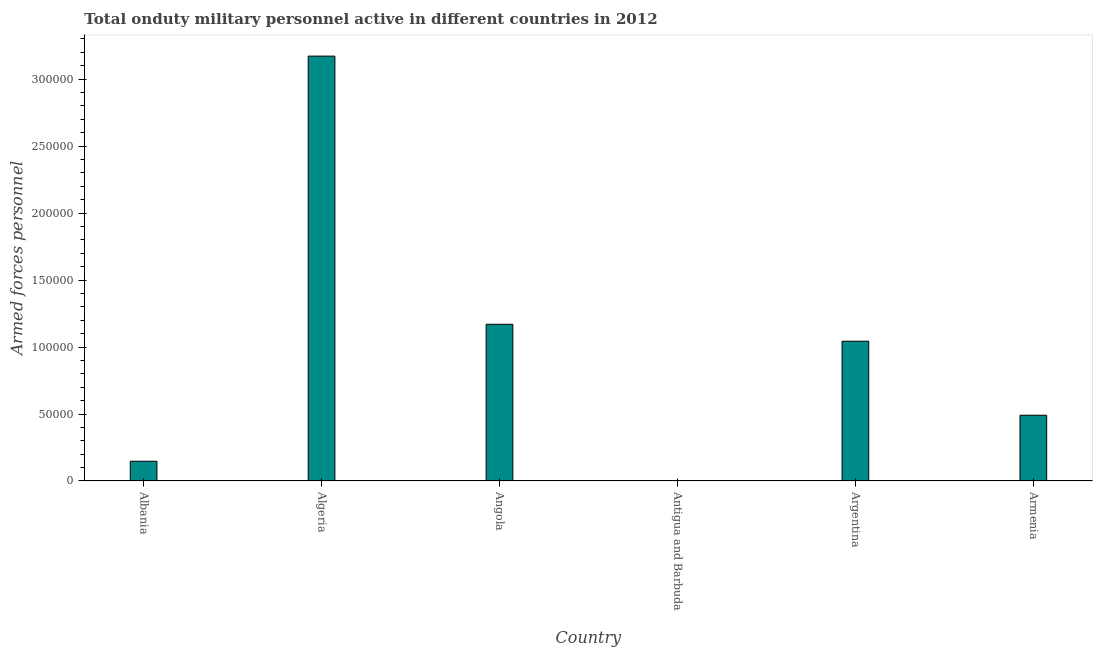Does the graph contain any zero values?
Your answer should be compact. No. Does the graph contain grids?
Your answer should be very brief. No. What is the title of the graph?
Your response must be concise. Total onduty military personnel active in different countries in 2012. What is the label or title of the Y-axis?
Offer a very short reply. Armed forces personnel. What is the number of armed forces personnel in Albania?
Keep it short and to the point. 1.48e+04. Across all countries, what is the maximum number of armed forces personnel?
Provide a succinct answer. 3.17e+05. Across all countries, what is the minimum number of armed forces personnel?
Provide a short and direct response. 180. In which country was the number of armed forces personnel maximum?
Your answer should be compact. Algeria. In which country was the number of armed forces personnel minimum?
Provide a succinct answer. Antigua and Barbuda. What is the sum of the number of armed forces personnel?
Offer a very short reply. 6.03e+05. What is the difference between the number of armed forces personnel in Argentina and Armenia?
Provide a succinct answer. 5.52e+04. What is the average number of armed forces personnel per country?
Offer a very short reply. 1.00e+05. What is the median number of armed forces personnel?
Your answer should be very brief. 7.67e+04. In how many countries, is the number of armed forces personnel greater than 100000 ?
Offer a very short reply. 3. What is the ratio of the number of armed forces personnel in Antigua and Barbuda to that in Armenia?
Provide a short and direct response. 0. Is the number of armed forces personnel in Antigua and Barbuda less than that in Armenia?
Keep it short and to the point. Yes. Is the difference between the number of armed forces personnel in Angola and Antigua and Barbuda greater than the difference between any two countries?
Your answer should be compact. No. What is the difference between the highest and the second highest number of armed forces personnel?
Your answer should be very brief. 2.00e+05. What is the difference between the highest and the lowest number of armed forces personnel?
Provide a succinct answer. 3.17e+05. Are all the bars in the graph horizontal?
Offer a very short reply. No. What is the Armed forces personnel of Albania?
Offer a terse response. 1.48e+04. What is the Armed forces personnel of Algeria?
Offer a very short reply. 3.17e+05. What is the Armed forces personnel of Angola?
Keep it short and to the point. 1.17e+05. What is the Armed forces personnel of Antigua and Barbuda?
Your answer should be very brief. 180. What is the Armed forces personnel of Argentina?
Your answer should be compact. 1.04e+05. What is the Armed forces personnel of Armenia?
Give a very brief answer. 4.91e+04. What is the difference between the Armed forces personnel in Albania and Algeria?
Offer a terse response. -3.02e+05. What is the difference between the Armed forces personnel in Albania and Angola?
Your answer should be compact. -1.02e+05. What is the difference between the Armed forces personnel in Albania and Antigua and Barbuda?
Your answer should be compact. 1.46e+04. What is the difference between the Armed forces personnel in Albania and Argentina?
Provide a succinct answer. -8.96e+04. What is the difference between the Armed forces personnel in Albania and Armenia?
Give a very brief answer. -3.44e+04. What is the difference between the Armed forces personnel in Algeria and Angola?
Provide a short and direct response. 2.00e+05. What is the difference between the Armed forces personnel in Algeria and Antigua and Barbuda?
Your answer should be compact. 3.17e+05. What is the difference between the Armed forces personnel in Algeria and Argentina?
Keep it short and to the point. 2.13e+05. What is the difference between the Armed forces personnel in Algeria and Armenia?
Give a very brief answer. 2.68e+05. What is the difference between the Armed forces personnel in Angola and Antigua and Barbuda?
Your response must be concise. 1.17e+05. What is the difference between the Armed forces personnel in Angola and Argentina?
Offer a terse response. 1.26e+04. What is the difference between the Armed forces personnel in Angola and Armenia?
Keep it short and to the point. 6.79e+04. What is the difference between the Armed forces personnel in Antigua and Barbuda and Argentina?
Offer a terse response. -1.04e+05. What is the difference between the Armed forces personnel in Antigua and Barbuda and Armenia?
Offer a terse response. -4.89e+04. What is the difference between the Armed forces personnel in Argentina and Armenia?
Provide a succinct answer. 5.52e+04. What is the ratio of the Armed forces personnel in Albania to that in Algeria?
Your answer should be compact. 0.05. What is the ratio of the Armed forces personnel in Albania to that in Angola?
Provide a short and direct response. 0.13. What is the ratio of the Armed forces personnel in Albania to that in Antigua and Barbuda?
Ensure brevity in your answer.  81.94. What is the ratio of the Armed forces personnel in Albania to that in Argentina?
Offer a terse response. 0.14. What is the ratio of the Armed forces personnel in Albania to that in Armenia?
Give a very brief answer. 0.3. What is the ratio of the Armed forces personnel in Algeria to that in Angola?
Provide a succinct answer. 2.71. What is the ratio of the Armed forces personnel in Algeria to that in Antigua and Barbuda?
Your answer should be compact. 1762.22. What is the ratio of the Armed forces personnel in Algeria to that in Argentina?
Your answer should be very brief. 3.04. What is the ratio of the Armed forces personnel in Algeria to that in Armenia?
Provide a succinct answer. 6.46. What is the ratio of the Armed forces personnel in Angola to that in Antigua and Barbuda?
Keep it short and to the point. 650. What is the ratio of the Armed forces personnel in Angola to that in Argentina?
Offer a very short reply. 1.12. What is the ratio of the Armed forces personnel in Angola to that in Armenia?
Provide a short and direct response. 2.38. What is the ratio of the Armed forces personnel in Antigua and Barbuda to that in Argentina?
Provide a short and direct response. 0. What is the ratio of the Armed forces personnel in Antigua and Barbuda to that in Armenia?
Your answer should be very brief. 0. What is the ratio of the Armed forces personnel in Argentina to that in Armenia?
Keep it short and to the point. 2.12. 